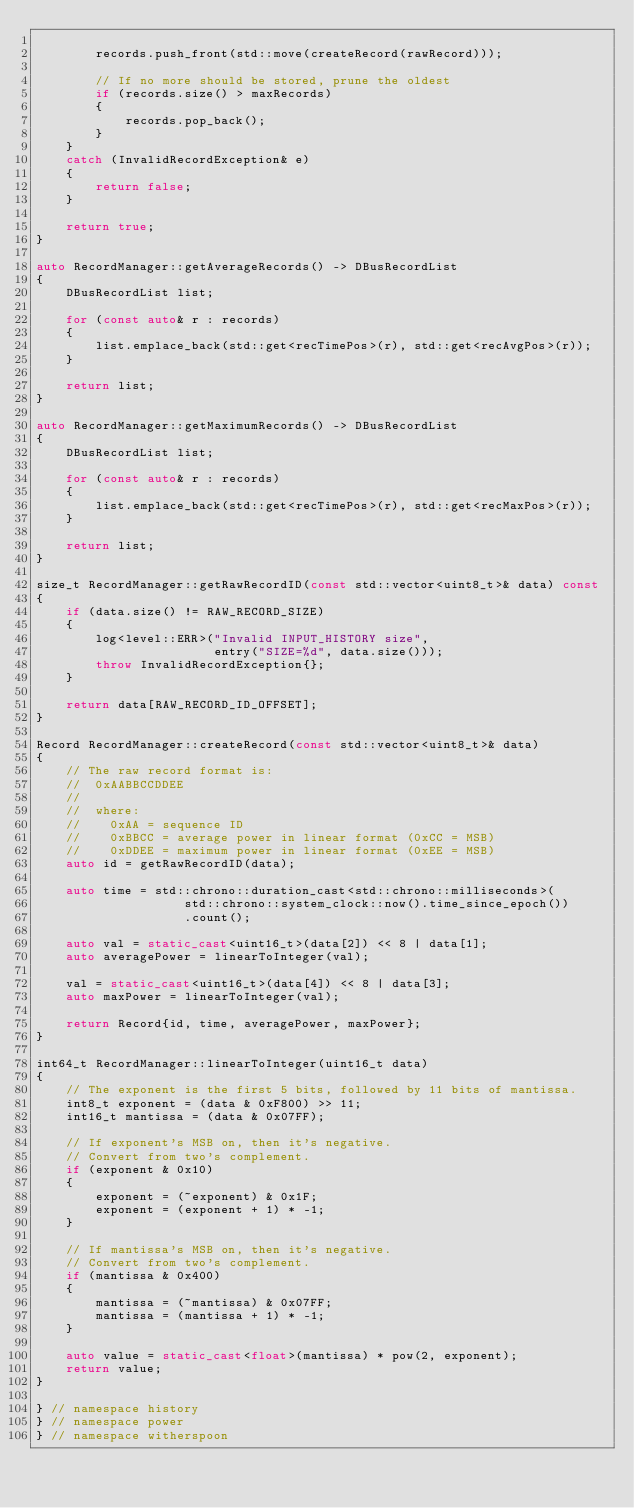Convert code to text. <code><loc_0><loc_0><loc_500><loc_500><_C++_>
        records.push_front(std::move(createRecord(rawRecord)));

        // If no more should be stored, prune the oldest
        if (records.size() > maxRecords)
        {
            records.pop_back();
        }
    }
    catch (InvalidRecordException& e)
    {
        return false;
    }

    return true;
}

auto RecordManager::getAverageRecords() -> DBusRecordList
{
    DBusRecordList list;

    for (const auto& r : records)
    {
        list.emplace_back(std::get<recTimePos>(r), std::get<recAvgPos>(r));
    }

    return list;
}

auto RecordManager::getMaximumRecords() -> DBusRecordList
{
    DBusRecordList list;

    for (const auto& r : records)
    {
        list.emplace_back(std::get<recTimePos>(r), std::get<recMaxPos>(r));
    }

    return list;
}

size_t RecordManager::getRawRecordID(const std::vector<uint8_t>& data) const
{
    if (data.size() != RAW_RECORD_SIZE)
    {
        log<level::ERR>("Invalid INPUT_HISTORY size",
                        entry("SIZE=%d", data.size()));
        throw InvalidRecordException{};
    }

    return data[RAW_RECORD_ID_OFFSET];
}

Record RecordManager::createRecord(const std::vector<uint8_t>& data)
{
    // The raw record format is:
    //  0xAABBCCDDEE
    //
    //  where:
    //    0xAA = sequence ID
    //    0xBBCC = average power in linear format (0xCC = MSB)
    //    0xDDEE = maximum power in linear format (0xEE = MSB)
    auto id = getRawRecordID(data);

    auto time = std::chrono::duration_cast<std::chrono::milliseconds>(
                    std::chrono::system_clock::now().time_since_epoch())
                    .count();

    auto val = static_cast<uint16_t>(data[2]) << 8 | data[1];
    auto averagePower = linearToInteger(val);

    val = static_cast<uint16_t>(data[4]) << 8 | data[3];
    auto maxPower = linearToInteger(val);

    return Record{id, time, averagePower, maxPower};
}

int64_t RecordManager::linearToInteger(uint16_t data)
{
    // The exponent is the first 5 bits, followed by 11 bits of mantissa.
    int8_t exponent = (data & 0xF800) >> 11;
    int16_t mantissa = (data & 0x07FF);

    // If exponent's MSB on, then it's negative.
    // Convert from two's complement.
    if (exponent & 0x10)
    {
        exponent = (~exponent) & 0x1F;
        exponent = (exponent + 1) * -1;
    }

    // If mantissa's MSB on, then it's negative.
    // Convert from two's complement.
    if (mantissa & 0x400)
    {
        mantissa = (~mantissa) & 0x07FF;
        mantissa = (mantissa + 1) * -1;
    }

    auto value = static_cast<float>(mantissa) * pow(2, exponent);
    return value;
}

} // namespace history
} // namespace power
} // namespace witherspoon
</code> 